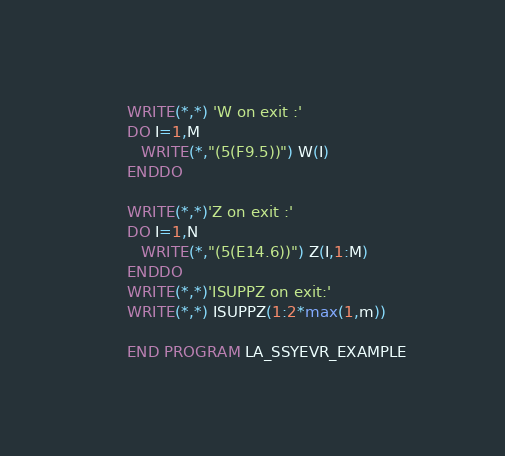<code> <loc_0><loc_0><loc_500><loc_500><_FORTRAN_>      WRITE(*,*) 'W on exit :'
      DO I=1,M
         WRITE(*,"(5(F9.5))") W(I)
      ENDDO
      
      WRITE(*,*)'Z on exit :'
      DO I=1,N
         WRITE(*,"(5(E14.6))") Z(I,1:M)
      ENDDO
      WRITE(*,*)'ISUPPZ on exit:'
      WRITE(*,*) ISUPPZ(1:2*max(1,m))

      END PROGRAM LA_SSYEVR_EXAMPLE
</code> 